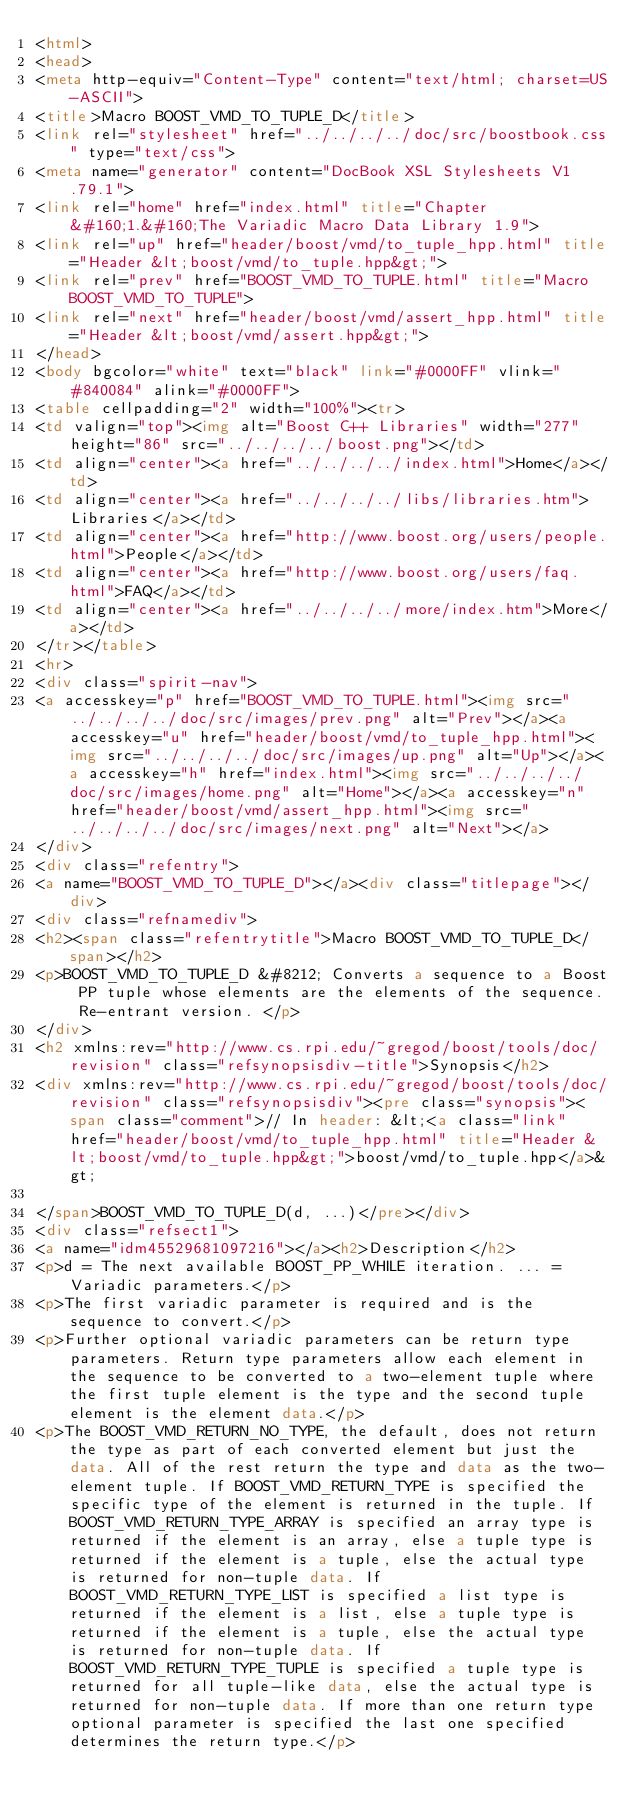Convert code to text. <code><loc_0><loc_0><loc_500><loc_500><_HTML_><html>
<head>
<meta http-equiv="Content-Type" content="text/html; charset=US-ASCII">
<title>Macro BOOST_VMD_TO_TUPLE_D</title>
<link rel="stylesheet" href="../../../../doc/src/boostbook.css" type="text/css">
<meta name="generator" content="DocBook XSL Stylesheets V1.79.1">
<link rel="home" href="index.html" title="Chapter&#160;1.&#160;The Variadic Macro Data Library 1.9">
<link rel="up" href="header/boost/vmd/to_tuple_hpp.html" title="Header &lt;boost/vmd/to_tuple.hpp&gt;">
<link rel="prev" href="BOOST_VMD_TO_TUPLE.html" title="Macro BOOST_VMD_TO_TUPLE">
<link rel="next" href="header/boost/vmd/assert_hpp.html" title="Header &lt;boost/vmd/assert.hpp&gt;">
</head>
<body bgcolor="white" text="black" link="#0000FF" vlink="#840084" alink="#0000FF">
<table cellpadding="2" width="100%"><tr>
<td valign="top"><img alt="Boost C++ Libraries" width="277" height="86" src="../../../../boost.png"></td>
<td align="center"><a href="../../../../index.html">Home</a></td>
<td align="center"><a href="../../../../libs/libraries.htm">Libraries</a></td>
<td align="center"><a href="http://www.boost.org/users/people.html">People</a></td>
<td align="center"><a href="http://www.boost.org/users/faq.html">FAQ</a></td>
<td align="center"><a href="../../../../more/index.htm">More</a></td>
</tr></table>
<hr>
<div class="spirit-nav">
<a accesskey="p" href="BOOST_VMD_TO_TUPLE.html"><img src="../../../../doc/src/images/prev.png" alt="Prev"></a><a accesskey="u" href="header/boost/vmd/to_tuple_hpp.html"><img src="../../../../doc/src/images/up.png" alt="Up"></a><a accesskey="h" href="index.html"><img src="../../../../doc/src/images/home.png" alt="Home"></a><a accesskey="n" href="header/boost/vmd/assert_hpp.html"><img src="../../../../doc/src/images/next.png" alt="Next"></a>
</div>
<div class="refentry">
<a name="BOOST_VMD_TO_TUPLE_D"></a><div class="titlepage"></div>
<div class="refnamediv">
<h2><span class="refentrytitle">Macro BOOST_VMD_TO_TUPLE_D</span></h2>
<p>BOOST_VMD_TO_TUPLE_D &#8212; Converts a sequence to a Boost PP tuple whose elements are the elements of the sequence. Re-entrant version. </p>
</div>
<h2 xmlns:rev="http://www.cs.rpi.edu/~gregod/boost/tools/doc/revision" class="refsynopsisdiv-title">Synopsis</h2>
<div xmlns:rev="http://www.cs.rpi.edu/~gregod/boost/tools/doc/revision" class="refsynopsisdiv"><pre class="synopsis"><span class="comment">// In header: &lt;<a class="link" href="header/boost/vmd/to_tuple_hpp.html" title="Header &lt;boost/vmd/to_tuple.hpp&gt;">boost/vmd/to_tuple.hpp</a>&gt;

</span>BOOST_VMD_TO_TUPLE_D(d, ...)</pre></div>
<div class="refsect1">
<a name="idm45529681097216"></a><h2>Description</h2>
<p>d = The next available BOOST_PP_WHILE iteration. ... = Variadic parameters.</p>
<p>The first variadic parameter is required and is the sequence to convert.</p>
<p>Further optional variadic parameters can be return type parameters. Return type parameters allow each element in the sequence to be converted to a two-element tuple where the first tuple element is the type and the second tuple element is the element data.</p>
<p>The BOOST_VMD_RETURN_NO_TYPE, the default, does not return the type as part of each converted element but just the data. All of the rest return the type and data as the two-element tuple. If BOOST_VMD_RETURN_TYPE is specified the specific type of the element is returned in the tuple. If BOOST_VMD_RETURN_TYPE_ARRAY is specified an array type is returned if the element is an array, else a tuple type is returned if the element is a tuple, else the actual type is returned for non-tuple data. If BOOST_VMD_RETURN_TYPE_LIST is specified a list type is returned if the element is a list, else a tuple type is returned if the element is a tuple, else the actual type is returned for non-tuple data. If BOOST_VMD_RETURN_TYPE_TUPLE is specified a tuple type is returned for all tuple-like data, else the actual type is returned for non-tuple data. If more than one return type optional parameter is specified the last one specified determines the return type.</p></code> 